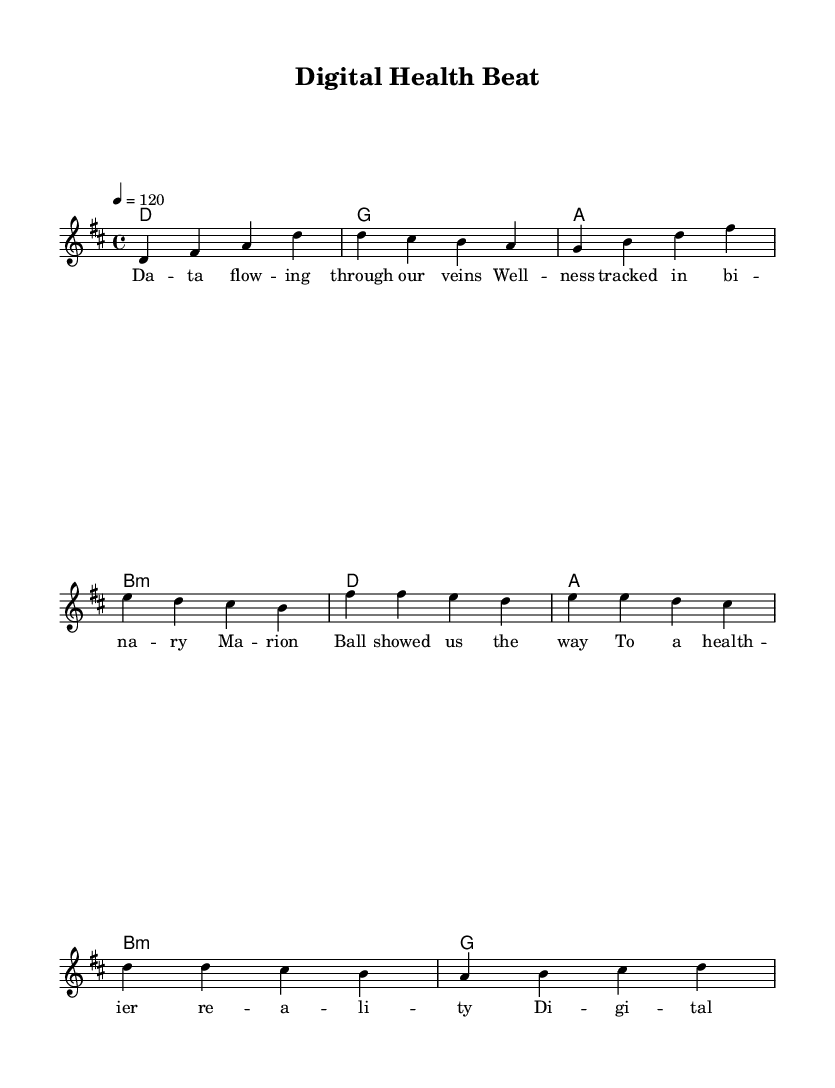What is the key signature of this music? The key signature is D major, which has two sharps: F# and C#. This is indicated at the beginning of the score, where the key signature is displayed.
Answer: D major What is the time signature of this music? The time signature is 4/4, which is shown at the start of the music. This means there are four beats in each measure and the quarter note receives one beat.
Answer: 4/4 What is the tempo marking for this piece? The tempo marking is 120 beats per minute. This is specified in the score with "4 = 120," indicating that the quarter note is the beat unit and should be played at 120 beats per minute.
Answer: 120 How many measures are there in the verse? The verse consists of four measures, which can be counted from the section of music labeled as "Verse." Each line of music represents a measure, and there are four lines in that section.
Answer: 4 Which line contains the lyrics related to health? The first verse contains lyrics that specifically refer to health, mentioning "wellness" and the influence of "Marion Ball," who is associated with health informatics.
Answer: Verse What is the repeating phrase in the chorus? The phrase "A healthier world for you and me" repeats the theme of health and community, which is a common feature in K-Pop lyrics, aiming to inspire positive change. This phrase captures the essence of the collaboration focused on health.
Answer: A healthier world for you and me 